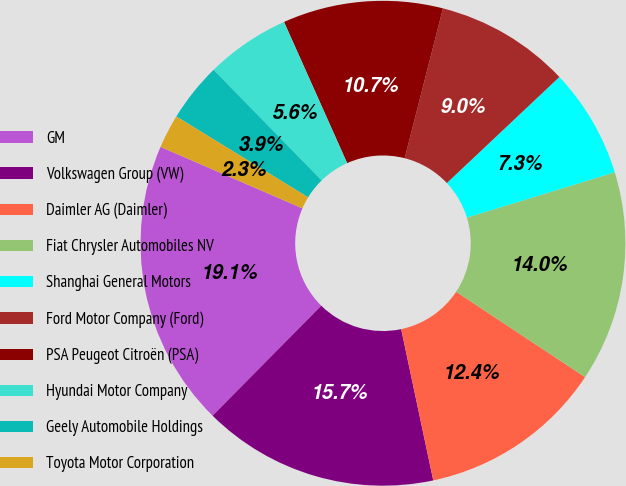<chart> <loc_0><loc_0><loc_500><loc_500><pie_chart><fcel>GM<fcel>Volkswagen Group (VW)<fcel>Daimler AG (Daimler)<fcel>Fiat Chrysler Automobiles NV<fcel>Shanghai General Motors<fcel>Ford Motor Company (Ford)<fcel>PSA Peugeot Citroën (PSA)<fcel>Hyundai Motor Company<fcel>Geely Automobile Holdings<fcel>Toyota Motor Corporation<nl><fcel>19.1%<fcel>15.73%<fcel>12.36%<fcel>14.04%<fcel>7.3%<fcel>8.99%<fcel>10.67%<fcel>5.62%<fcel>3.93%<fcel>2.25%<nl></chart> 